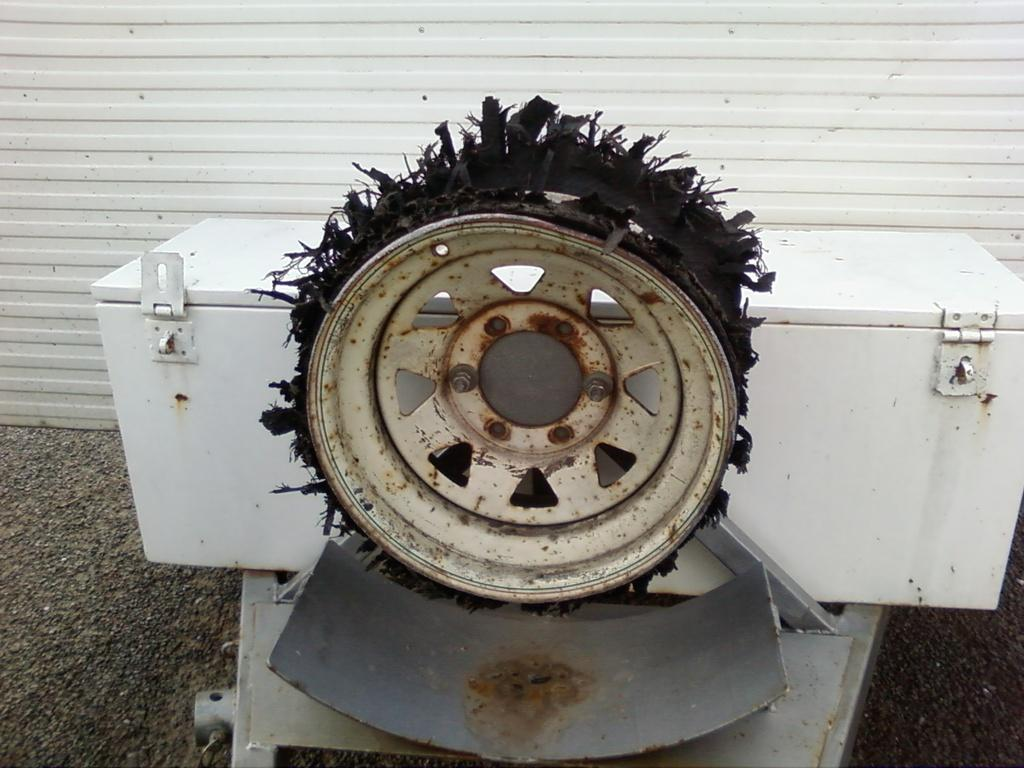What is the shape of the main object in the image? The main object in the image is round shaped. What can be seen on the surface of the round shaped object? There is some black color thing on the round shaped object. What is visible in the background of the image? There is a white trunk box and a white wall in the background of the image. Can you hear the bell ringing in the image? There is no bell present in the image, so it cannot be heard ringing. 